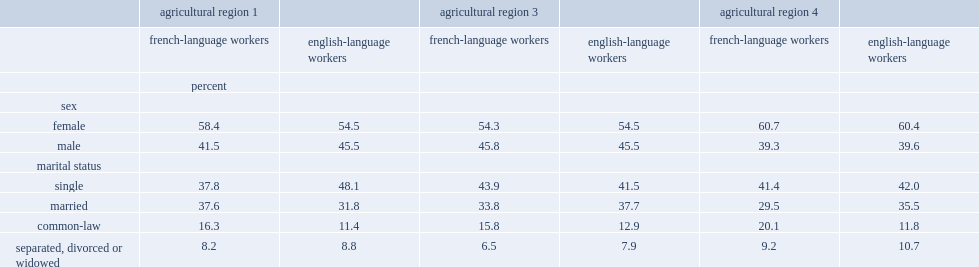In 2011, which group of people were more likely to work in the new brunswick agri-food sector, regardless of the linguistic grouping? male or female? Female. What is the range of the proportion of french-language female workers in all agir-food sectors? 54.3 60.7. In new brunswick's agricultural region 1, which sector of the female workers was more likely to work in the agri-food sector? french-language workers or english-language workers? French-language workers. Which sector of workers had a higher proportion of workers who were married or living in a common-law relationship in the new brunswick's agricultural regions 3 and 4? english-language workers or french-language workers? French-language workers french-language workers. Which sector workers in agricultural region 1 was more likely to be in a common-law relationship?french-language workers or english-language workers? French-language workers. Which sector workers in agricultural region 1 was more likely to be married? french-language workers or english-language workers? French-language workers. 